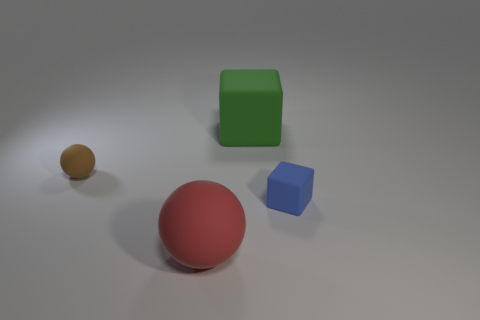There is a large matte thing in front of the brown matte object; is its shape the same as the brown matte object?
Offer a terse response. Yes. Is the number of big green rubber things to the left of the large red matte sphere greater than the number of cubes?
Provide a succinct answer. No. How many big things are both in front of the small brown object and behind the tiny brown object?
Offer a terse response. 0. There is a thing that is left of the ball in front of the blue thing; what is its color?
Give a very brief answer. Brown. How many large matte things have the same color as the tiny cube?
Your answer should be compact. 0. There is a small ball; does it have the same color as the big object that is on the right side of the big red matte ball?
Provide a succinct answer. No. Is the number of small green blocks less than the number of big rubber things?
Your answer should be very brief. Yes. Are there more green objects that are to the right of the tiny blue cube than green matte objects that are on the left side of the red matte thing?
Make the answer very short. No. Is the large block made of the same material as the brown object?
Give a very brief answer. Yes. What number of green cubes are in front of the big thing that is in front of the big green object?
Ensure brevity in your answer.  0. 